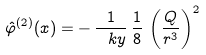<formula> <loc_0><loc_0><loc_500><loc_500>\hat { \varphi } ^ { ( 2 ) } ( x ) = - \, \frac { 1 } { \ k y } \, \frac { 1 } { 8 } \, \left ( \frac { Q } { r ^ { 3 } } \right ) ^ { 2 }</formula> 